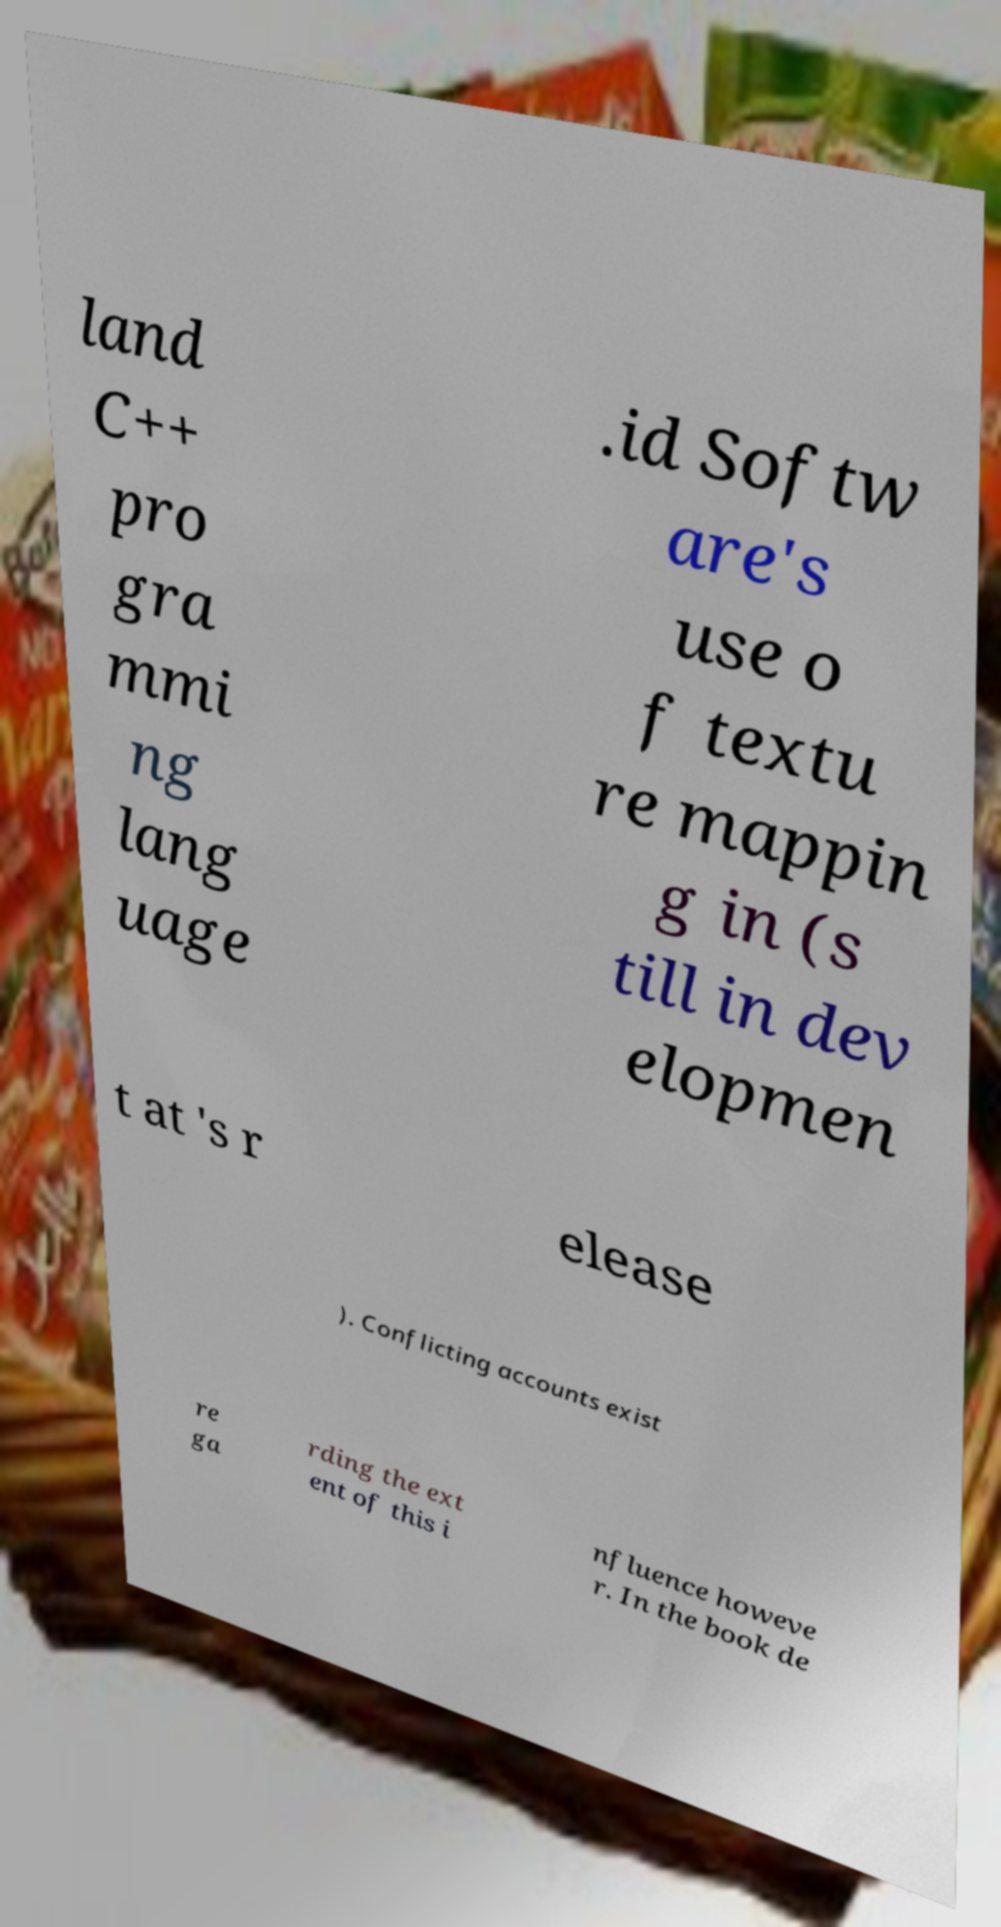What messages or text are displayed in this image? I need them in a readable, typed format. land C++ pro gra mmi ng lang uage .id Softw are's use o f textu re mappin g in (s till in dev elopmen t at 's r elease ). Conflicting accounts exist re ga rding the ext ent of this i nfluence howeve r. In the book de 